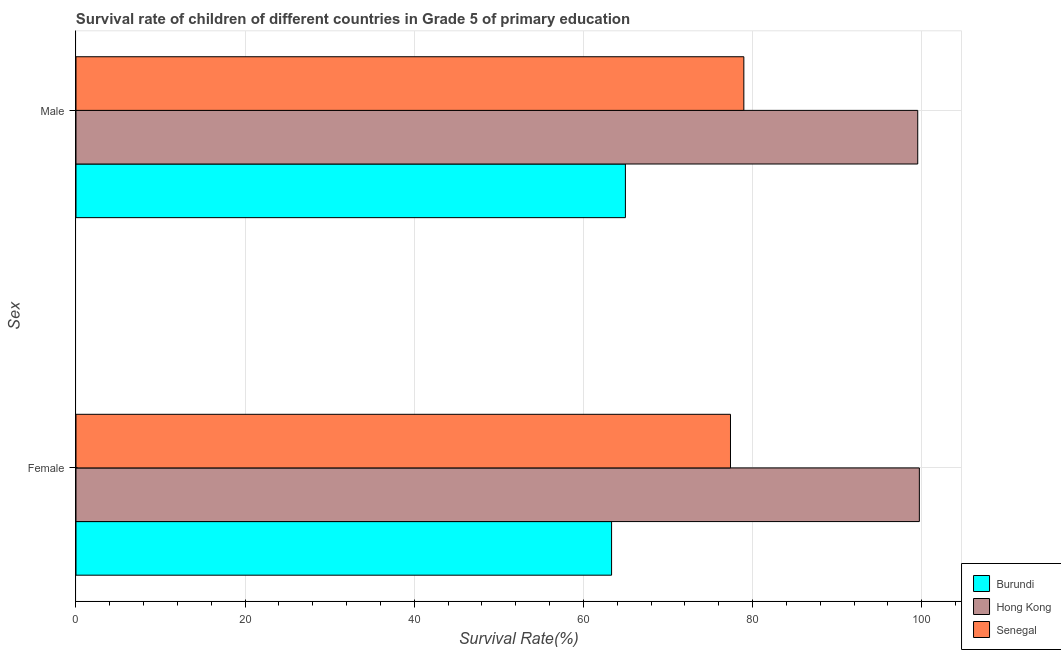What is the label of the 2nd group of bars from the top?
Your answer should be compact. Female. What is the survival rate of male students in primary education in Senegal?
Keep it short and to the point. 78.97. Across all countries, what is the maximum survival rate of female students in primary education?
Give a very brief answer. 99.72. Across all countries, what is the minimum survival rate of female students in primary education?
Offer a very short reply. 63.33. In which country was the survival rate of female students in primary education maximum?
Your answer should be very brief. Hong Kong. In which country was the survival rate of female students in primary education minimum?
Ensure brevity in your answer.  Burundi. What is the total survival rate of male students in primary education in the graph?
Ensure brevity in your answer.  243.46. What is the difference between the survival rate of male students in primary education in Hong Kong and that in Senegal?
Offer a terse response. 20.56. What is the difference between the survival rate of female students in primary education in Senegal and the survival rate of male students in primary education in Hong Kong?
Your answer should be very brief. -22.14. What is the average survival rate of male students in primary education per country?
Provide a short and direct response. 81.15. What is the difference between the survival rate of male students in primary education and survival rate of female students in primary education in Hong Kong?
Ensure brevity in your answer.  -0.19. In how many countries, is the survival rate of female students in primary education greater than 40 %?
Offer a terse response. 3. What is the ratio of the survival rate of female students in primary education in Hong Kong to that in Senegal?
Your response must be concise. 1.29. What does the 2nd bar from the top in Male represents?
Offer a terse response. Hong Kong. What does the 3rd bar from the bottom in Male represents?
Offer a very short reply. Senegal. What is the difference between two consecutive major ticks on the X-axis?
Give a very brief answer. 20. Are the values on the major ticks of X-axis written in scientific E-notation?
Provide a succinct answer. No. Does the graph contain any zero values?
Make the answer very short. No. Does the graph contain grids?
Your answer should be compact. Yes. How many legend labels are there?
Give a very brief answer. 3. What is the title of the graph?
Make the answer very short. Survival rate of children of different countries in Grade 5 of primary education. Does "Tanzania" appear as one of the legend labels in the graph?
Make the answer very short. No. What is the label or title of the X-axis?
Your answer should be very brief. Survival Rate(%). What is the label or title of the Y-axis?
Ensure brevity in your answer.  Sex. What is the Survival Rate(%) in Burundi in Female?
Ensure brevity in your answer.  63.33. What is the Survival Rate(%) in Hong Kong in Female?
Your response must be concise. 99.72. What is the Survival Rate(%) in Senegal in Female?
Give a very brief answer. 77.39. What is the Survival Rate(%) in Burundi in Male?
Your answer should be compact. 64.96. What is the Survival Rate(%) in Hong Kong in Male?
Your answer should be very brief. 99.53. What is the Survival Rate(%) of Senegal in Male?
Give a very brief answer. 78.97. Across all Sex, what is the maximum Survival Rate(%) of Burundi?
Offer a very short reply. 64.96. Across all Sex, what is the maximum Survival Rate(%) of Hong Kong?
Offer a very short reply. 99.72. Across all Sex, what is the maximum Survival Rate(%) of Senegal?
Offer a very short reply. 78.97. Across all Sex, what is the minimum Survival Rate(%) in Burundi?
Your answer should be very brief. 63.33. Across all Sex, what is the minimum Survival Rate(%) of Hong Kong?
Make the answer very short. 99.53. Across all Sex, what is the minimum Survival Rate(%) in Senegal?
Make the answer very short. 77.39. What is the total Survival Rate(%) of Burundi in the graph?
Provide a short and direct response. 128.29. What is the total Survival Rate(%) in Hong Kong in the graph?
Provide a succinct answer. 199.25. What is the total Survival Rate(%) of Senegal in the graph?
Your response must be concise. 156.36. What is the difference between the Survival Rate(%) of Burundi in Female and that in Male?
Offer a terse response. -1.64. What is the difference between the Survival Rate(%) of Hong Kong in Female and that in Male?
Provide a short and direct response. 0.19. What is the difference between the Survival Rate(%) of Senegal in Female and that in Male?
Give a very brief answer. -1.58. What is the difference between the Survival Rate(%) in Burundi in Female and the Survival Rate(%) in Hong Kong in Male?
Provide a succinct answer. -36.2. What is the difference between the Survival Rate(%) in Burundi in Female and the Survival Rate(%) in Senegal in Male?
Ensure brevity in your answer.  -15.64. What is the difference between the Survival Rate(%) of Hong Kong in Female and the Survival Rate(%) of Senegal in Male?
Your response must be concise. 20.75. What is the average Survival Rate(%) of Burundi per Sex?
Provide a succinct answer. 64.15. What is the average Survival Rate(%) of Hong Kong per Sex?
Ensure brevity in your answer.  99.63. What is the average Survival Rate(%) of Senegal per Sex?
Ensure brevity in your answer.  78.18. What is the difference between the Survival Rate(%) of Burundi and Survival Rate(%) of Hong Kong in Female?
Your response must be concise. -36.39. What is the difference between the Survival Rate(%) in Burundi and Survival Rate(%) in Senegal in Female?
Your answer should be very brief. -14.06. What is the difference between the Survival Rate(%) in Hong Kong and Survival Rate(%) in Senegal in Female?
Give a very brief answer. 22.33. What is the difference between the Survival Rate(%) in Burundi and Survival Rate(%) in Hong Kong in Male?
Your answer should be very brief. -34.57. What is the difference between the Survival Rate(%) of Burundi and Survival Rate(%) of Senegal in Male?
Your answer should be very brief. -14. What is the difference between the Survival Rate(%) in Hong Kong and Survival Rate(%) in Senegal in Male?
Ensure brevity in your answer.  20.56. What is the ratio of the Survival Rate(%) of Burundi in Female to that in Male?
Provide a succinct answer. 0.97. What is the ratio of the Survival Rate(%) of Hong Kong in Female to that in Male?
Ensure brevity in your answer.  1. What is the ratio of the Survival Rate(%) of Senegal in Female to that in Male?
Make the answer very short. 0.98. What is the difference between the highest and the second highest Survival Rate(%) in Burundi?
Your response must be concise. 1.64. What is the difference between the highest and the second highest Survival Rate(%) of Hong Kong?
Ensure brevity in your answer.  0.19. What is the difference between the highest and the second highest Survival Rate(%) of Senegal?
Your response must be concise. 1.58. What is the difference between the highest and the lowest Survival Rate(%) in Burundi?
Ensure brevity in your answer.  1.64. What is the difference between the highest and the lowest Survival Rate(%) of Hong Kong?
Offer a very short reply. 0.19. What is the difference between the highest and the lowest Survival Rate(%) in Senegal?
Offer a terse response. 1.58. 